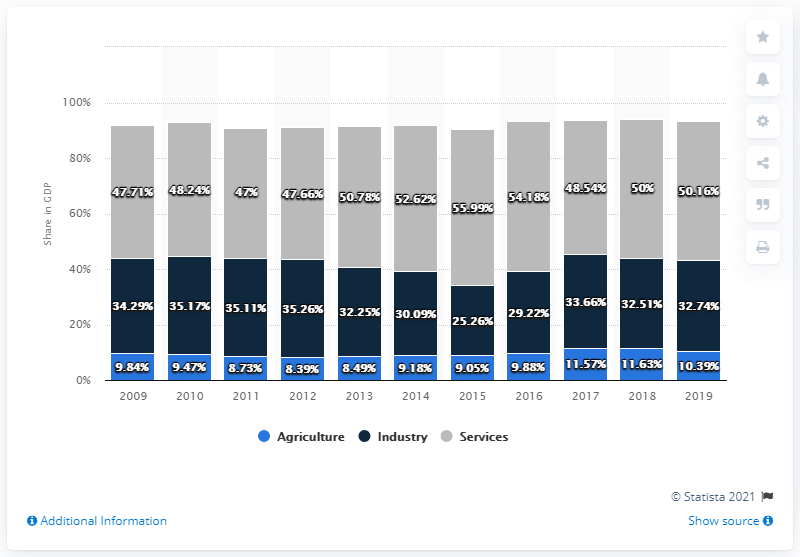Outline some significant characteristics in this image. The highest percentage in agriculture is 11.63%. The total of the sectors in 2010 was 92.88. 